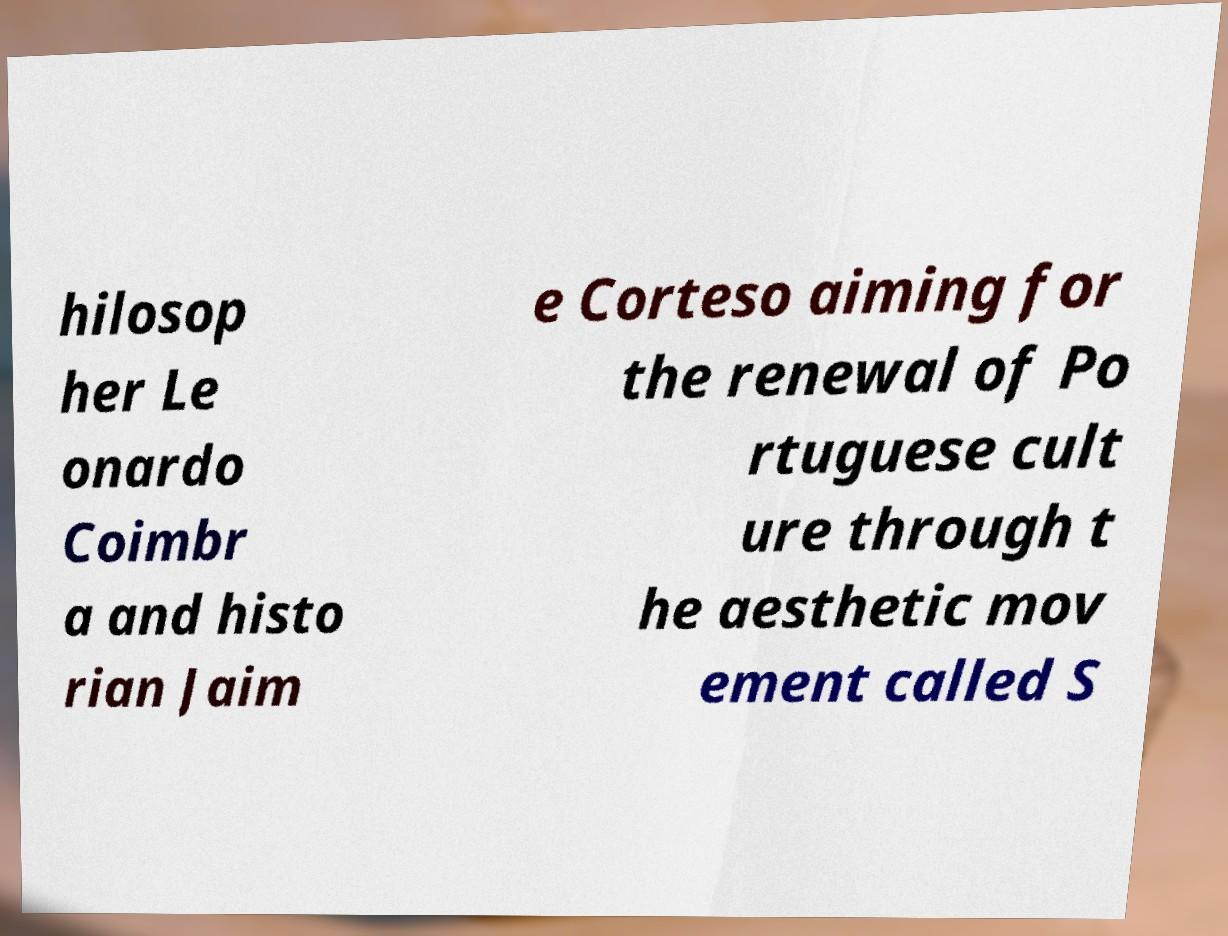Can you accurately transcribe the text from the provided image for me? hilosop her Le onardo Coimbr a and histo rian Jaim e Corteso aiming for the renewal of Po rtuguese cult ure through t he aesthetic mov ement called S 